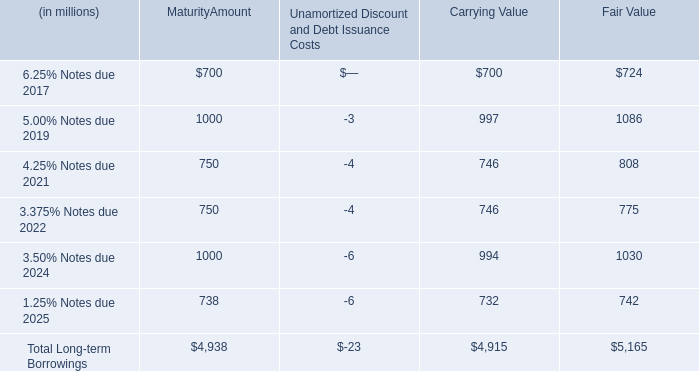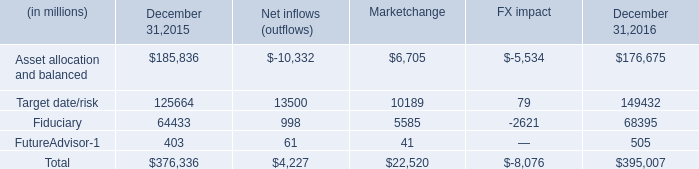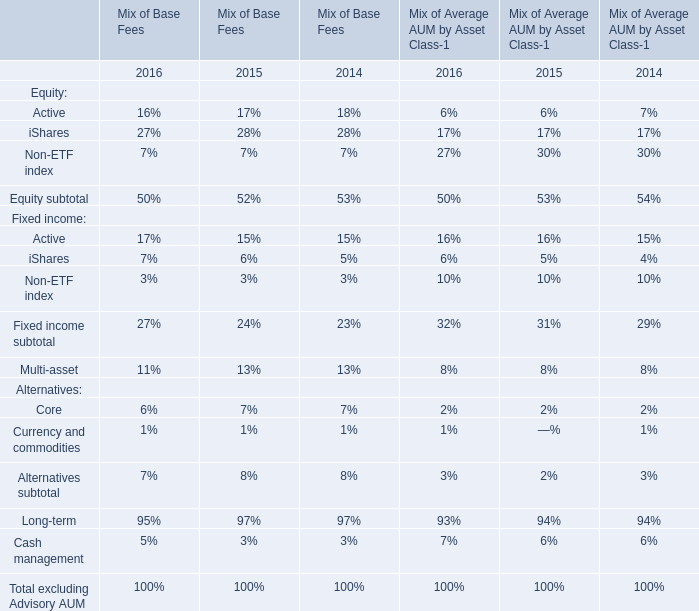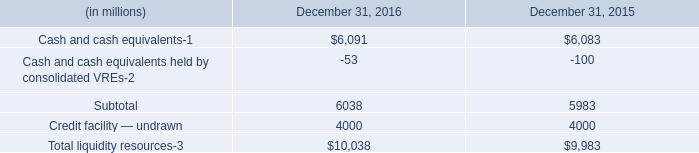what are the pre tax gains recognized in other comprehensive income in 2016? 
Computations: (14 + 8)
Answer: 22.0. what is the percentage change in total multi-asset aum during 2016? 
Computations: ((395007 - 376336) / 376336)
Answer: 0.04961. 